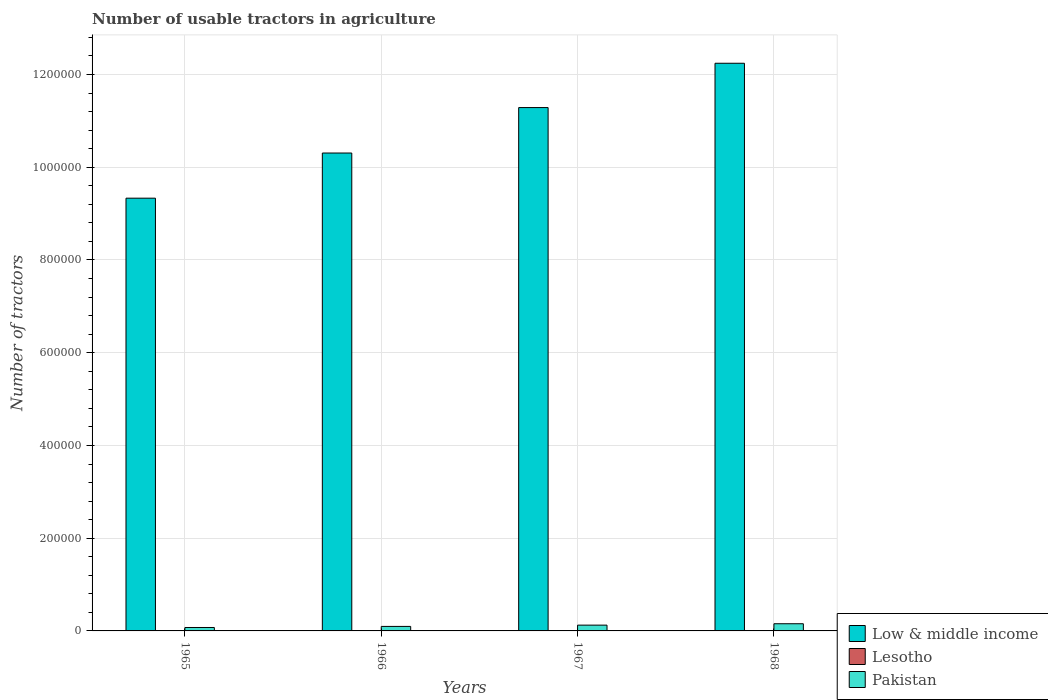How many different coloured bars are there?
Provide a succinct answer. 3. How many groups of bars are there?
Offer a very short reply. 4. How many bars are there on the 2nd tick from the left?
Provide a succinct answer. 3. How many bars are there on the 3rd tick from the right?
Make the answer very short. 3. What is the label of the 2nd group of bars from the left?
Offer a terse response. 1966. In how many cases, is the number of bars for a given year not equal to the number of legend labels?
Your answer should be very brief. 0. What is the number of usable tractors in agriculture in Pakistan in 1968?
Give a very brief answer. 1.55e+04. Across all years, what is the maximum number of usable tractors in agriculture in Low & middle income?
Provide a succinct answer. 1.22e+06. Across all years, what is the minimum number of usable tractors in agriculture in Pakistan?
Offer a terse response. 7388. In which year was the number of usable tractors in agriculture in Pakistan maximum?
Your answer should be very brief. 1968. In which year was the number of usable tractors in agriculture in Pakistan minimum?
Ensure brevity in your answer.  1965. What is the total number of usable tractors in agriculture in Low & middle income in the graph?
Make the answer very short. 4.32e+06. What is the difference between the number of usable tractors in agriculture in Lesotho in 1966 and that in 1968?
Provide a short and direct response. -60. What is the difference between the number of usable tractors in agriculture in Pakistan in 1965 and the number of usable tractors in agriculture in Lesotho in 1966?
Your answer should be very brief. 7128. What is the average number of usable tractors in agriculture in Pakistan per year?
Offer a terse response. 1.13e+04. In the year 1968, what is the difference between the number of usable tractors in agriculture in Pakistan and number of usable tractors in agriculture in Lesotho?
Offer a very short reply. 1.52e+04. In how many years, is the number of usable tractors in agriculture in Pakistan greater than 680000?
Provide a short and direct response. 0. What is the ratio of the number of usable tractors in agriculture in Low & middle income in 1965 to that in 1967?
Keep it short and to the point. 0.83. Is the number of usable tractors in agriculture in Low & middle income in 1965 less than that in 1967?
Keep it short and to the point. Yes. Is the difference between the number of usable tractors in agriculture in Pakistan in 1966 and 1967 greater than the difference between the number of usable tractors in agriculture in Lesotho in 1966 and 1967?
Offer a very short reply. No. What is the difference between the highest and the lowest number of usable tractors in agriculture in Low & middle income?
Offer a terse response. 2.91e+05. In how many years, is the number of usable tractors in agriculture in Lesotho greater than the average number of usable tractors in agriculture in Lesotho taken over all years?
Provide a short and direct response. 2. What does the 3rd bar from the right in 1967 represents?
Make the answer very short. Low & middle income. Is it the case that in every year, the sum of the number of usable tractors in agriculture in Low & middle income and number of usable tractors in agriculture in Pakistan is greater than the number of usable tractors in agriculture in Lesotho?
Your response must be concise. Yes. Are all the bars in the graph horizontal?
Make the answer very short. No. How many years are there in the graph?
Offer a terse response. 4. What is the difference between two consecutive major ticks on the Y-axis?
Your response must be concise. 2.00e+05. Are the values on the major ticks of Y-axis written in scientific E-notation?
Give a very brief answer. No. Where does the legend appear in the graph?
Give a very brief answer. Bottom right. How many legend labels are there?
Your answer should be very brief. 3. How are the legend labels stacked?
Keep it short and to the point. Vertical. What is the title of the graph?
Keep it short and to the point. Number of usable tractors in agriculture. What is the label or title of the X-axis?
Keep it short and to the point. Years. What is the label or title of the Y-axis?
Offer a terse response. Number of tractors. What is the Number of tractors in Low & middle income in 1965?
Provide a short and direct response. 9.33e+05. What is the Number of tractors in Lesotho in 1965?
Give a very brief answer. 230. What is the Number of tractors in Pakistan in 1965?
Your answer should be very brief. 7388. What is the Number of tractors of Low & middle income in 1966?
Offer a terse response. 1.03e+06. What is the Number of tractors in Lesotho in 1966?
Your answer should be compact. 260. What is the Number of tractors in Pakistan in 1966?
Your answer should be compact. 9733. What is the Number of tractors of Low & middle income in 1967?
Give a very brief answer. 1.13e+06. What is the Number of tractors of Lesotho in 1967?
Keep it short and to the point. 290. What is the Number of tractors of Pakistan in 1967?
Keep it short and to the point. 1.25e+04. What is the Number of tractors in Low & middle income in 1968?
Make the answer very short. 1.22e+06. What is the Number of tractors of Lesotho in 1968?
Provide a short and direct response. 320. What is the Number of tractors in Pakistan in 1968?
Your answer should be compact. 1.55e+04. Across all years, what is the maximum Number of tractors of Low & middle income?
Provide a succinct answer. 1.22e+06. Across all years, what is the maximum Number of tractors of Lesotho?
Provide a succinct answer. 320. Across all years, what is the maximum Number of tractors in Pakistan?
Offer a very short reply. 1.55e+04. Across all years, what is the minimum Number of tractors in Low & middle income?
Offer a terse response. 9.33e+05. Across all years, what is the minimum Number of tractors in Lesotho?
Provide a succinct answer. 230. Across all years, what is the minimum Number of tractors of Pakistan?
Make the answer very short. 7388. What is the total Number of tractors in Low & middle income in the graph?
Provide a succinct answer. 4.32e+06. What is the total Number of tractors of Lesotho in the graph?
Your answer should be compact. 1100. What is the total Number of tractors in Pakistan in the graph?
Give a very brief answer. 4.51e+04. What is the difference between the Number of tractors of Low & middle income in 1965 and that in 1966?
Provide a short and direct response. -9.74e+04. What is the difference between the Number of tractors of Pakistan in 1965 and that in 1966?
Provide a short and direct response. -2345. What is the difference between the Number of tractors of Low & middle income in 1965 and that in 1967?
Your answer should be compact. -1.95e+05. What is the difference between the Number of tractors of Lesotho in 1965 and that in 1967?
Make the answer very short. -60. What is the difference between the Number of tractors in Pakistan in 1965 and that in 1967?
Your answer should be compact. -5112. What is the difference between the Number of tractors in Low & middle income in 1965 and that in 1968?
Provide a succinct answer. -2.91e+05. What is the difference between the Number of tractors in Lesotho in 1965 and that in 1968?
Provide a short and direct response. -90. What is the difference between the Number of tractors of Pakistan in 1965 and that in 1968?
Ensure brevity in your answer.  -8112. What is the difference between the Number of tractors in Low & middle income in 1966 and that in 1967?
Keep it short and to the point. -9.80e+04. What is the difference between the Number of tractors in Lesotho in 1966 and that in 1967?
Make the answer very short. -30. What is the difference between the Number of tractors of Pakistan in 1966 and that in 1967?
Provide a succinct answer. -2767. What is the difference between the Number of tractors in Low & middle income in 1966 and that in 1968?
Offer a very short reply. -1.94e+05. What is the difference between the Number of tractors of Lesotho in 1966 and that in 1968?
Your answer should be compact. -60. What is the difference between the Number of tractors in Pakistan in 1966 and that in 1968?
Your answer should be very brief. -5767. What is the difference between the Number of tractors in Low & middle income in 1967 and that in 1968?
Your answer should be compact. -9.56e+04. What is the difference between the Number of tractors in Pakistan in 1967 and that in 1968?
Ensure brevity in your answer.  -3000. What is the difference between the Number of tractors in Low & middle income in 1965 and the Number of tractors in Lesotho in 1966?
Your answer should be very brief. 9.33e+05. What is the difference between the Number of tractors of Low & middle income in 1965 and the Number of tractors of Pakistan in 1966?
Your response must be concise. 9.24e+05. What is the difference between the Number of tractors in Lesotho in 1965 and the Number of tractors in Pakistan in 1966?
Provide a succinct answer. -9503. What is the difference between the Number of tractors of Low & middle income in 1965 and the Number of tractors of Lesotho in 1967?
Offer a terse response. 9.33e+05. What is the difference between the Number of tractors in Low & middle income in 1965 and the Number of tractors in Pakistan in 1967?
Provide a short and direct response. 9.21e+05. What is the difference between the Number of tractors in Lesotho in 1965 and the Number of tractors in Pakistan in 1967?
Your answer should be compact. -1.23e+04. What is the difference between the Number of tractors of Low & middle income in 1965 and the Number of tractors of Lesotho in 1968?
Offer a very short reply. 9.33e+05. What is the difference between the Number of tractors in Low & middle income in 1965 and the Number of tractors in Pakistan in 1968?
Make the answer very short. 9.18e+05. What is the difference between the Number of tractors in Lesotho in 1965 and the Number of tractors in Pakistan in 1968?
Your answer should be compact. -1.53e+04. What is the difference between the Number of tractors of Low & middle income in 1966 and the Number of tractors of Lesotho in 1967?
Offer a very short reply. 1.03e+06. What is the difference between the Number of tractors of Low & middle income in 1966 and the Number of tractors of Pakistan in 1967?
Make the answer very short. 1.02e+06. What is the difference between the Number of tractors of Lesotho in 1966 and the Number of tractors of Pakistan in 1967?
Your response must be concise. -1.22e+04. What is the difference between the Number of tractors of Low & middle income in 1966 and the Number of tractors of Lesotho in 1968?
Give a very brief answer. 1.03e+06. What is the difference between the Number of tractors of Low & middle income in 1966 and the Number of tractors of Pakistan in 1968?
Your answer should be very brief. 1.02e+06. What is the difference between the Number of tractors in Lesotho in 1966 and the Number of tractors in Pakistan in 1968?
Offer a terse response. -1.52e+04. What is the difference between the Number of tractors in Low & middle income in 1967 and the Number of tractors in Lesotho in 1968?
Ensure brevity in your answer.  1.13e+06. What is the difference between the Number of tractors of Low & middle income in 1967 and the Number of tractors of Pakistan in 1968?
Offer a terse response. 1.11e+06. What is the difference between the Number of tractors in Lesotho in 1967 and the Number of tractors in Pakistan in 1968?
Offer a very short reply. -1.52e+04. What is the average Number of tractors of Low & middle income per year?
Your answer should be very brief. 1.08e+06. What is the average Number of tractors of Lesotho per year?
Your answer should be compact. 275. What is the average Number of tractors in Pakistan per year?
Your response must be concise. 1.13e+04. In the year 1965, what is the difference between the Number of tractors in Low & middle income and Number of tractors in Lesotho?
Your answer should be very brief. 9.33e+05. In the year 1965, what is the difference between the Number of tractors in Low & middle income and Number of tractors in Pakistan?
Keep it short and to the point. 9.26e+05. In the year 1965, what is the difference between the Number of tractors in Lesotho and Number of tractors in Pakistan?
Your answer should be very brief. -7158. In the year 1966, what is the difference between the Number of tractors of Low & middle income and Number of tractors of Lesotho?
Offer a terse response. 1.03e+06. In the year 1966, what is the difference between the Number of tractors in Low & middle income and Number of tractors in Pakistan?
Make the answer very short. 1.02e+06. In the year 1966, what is the difference between the Number of tractors of Lesotho and Number of tractors of Pakistan?
Your answer should be very brief. -9473. In the year 1967, what is the difference between the Number of tractors of Low & middle income and Number of tractors of Lesotho?
Your response must be concise. 1.13e+06. In the year 1967, what is the difference between the Number of tractors in Low & middle income and Number of tractors in Pakistan?
Your answer should be very brief. 1.12e+06. In the year 1967, what is the difference between the Number of tractors of Lesotho and Number of tractors of Pakistan?
Provide a short and direct response. -1.22e+04. In the year 1968, what is the difference between the Number of tractors of Low & middle income and Number of tractors of Lesotho?
Your response must be concise. 1.22e+06. In the year 1968, what is the difference between the Number of tractors in Low & middle income and Number of tractors in Pakistan?
Keep it short and to the point. 1.21e+06. In the year 1968, what is the difference between the Number of tractors of Lesotho and Number of tractors of Pakistan?
Provide a succinct answer. -1.52e+04. What is the ratio of the Number of tractors of Low & middle income in 1965 to that in 1966?
Your response must be concise. 0.91. What is the ratio of the Number of tractors in Lesotho in 1965 to that in 1966?
Offer a terse response. 0.88. What is the ratio of the Number of tractors of Pakistan in 1965 to that in 1966?
Ensure brevity in your answer.  0.76. What is the ratio of the Number of tractors of Low & middle income in 1965 to that in 1967?
Provide a short and direct response. 0.83. What is the ratio of the Number of tractors of Lesotho in 1965 to that in 1967?
Offer a very short reply. 0.79. What is the ratio of the Number of tractors in Pakistan in 1965 to that in 1967?
Keep it short and to the point. 0.59. What is the ratio of the Number of tractors of Low & middle income in 1965 to that in 1968?
Your answer should be very brief. 0.76. What is the ratio of the Number of tractors of Lesotho in 1965 to that in 1968?
Ensure brevity in your answer.  0.72. What is the ratio of the Number of tractors of Pakistan in 1965 to that in 1968?
Keep it short and to the point. 0.48. What is the ratio of the Number of tractors in Low & middle income in 1966 to that in 1967?
Offer a very short reply. 0.91. What is the ratio of the Number of tractors in Lesotho in 1966 to that in 1967?
Keep it short and to the point. 0.9. What is the ratio of the Number of tractors of Pakistan in 1966 to that in 1967?
Your response must be concise. 0.78. What is the ratio of the Number of tractors in Low & middle income in 1966 to that in 1968?
Provide a succinct answer. 0.84. What is the ratio of the Number of tractors of Lesotho in 1966 to that in 1968?
Offer a terse response. 0.81. What is the ratio of the Number of tractors in Pakistan in 1966 to that in 1968?
Offer a very short reply. 0.63. What is the ratio of the Number of tractors in Low & middle income in 1967 to that in 1968?
Your answer should be compact. 0.92. What is the ratio of the Number of tractors of Lesotho in 1967 to that in 1968?
Your answer should be very brief. 0.91. What is the ratio of the Number of tractors in Pakistan in 1967 to that in 1968?
Your answer should be very brief. 0.81. What is the difference between the highest and the second highest Number of tractors of Low & middle income?
Provide a short and direct response. 9.56e+04. What is the difference between the highest and the second highest Number of tractors of Lesotho?
Offer a terse response. 30. What is the difference between the highest and the second highest Number of tractors in Pakistan?
Provide a succinct answer. 3000. What is the difference between the highest and the lowest Number of tractors of Low & middle income?
Offer a very short reply. 2.91e+05. What is the difference between the highest and the lowest Number of tractors in Lesotho?
Provide a short and direct response. 90. What is the difference between the highest and the lowest Number of tractors in Pakistan?
Give a very brief answer. 8112. 